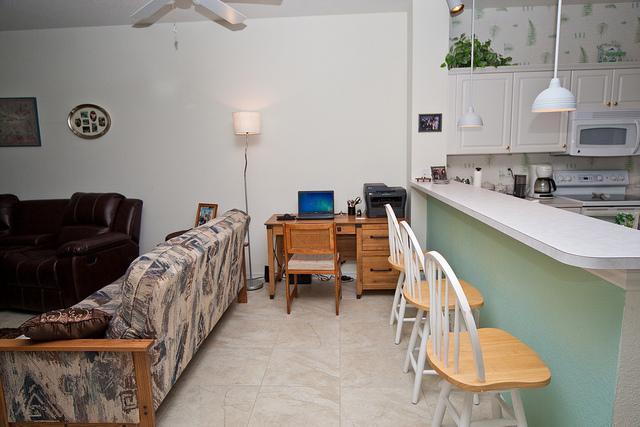How many couches are there?
Give a very brief answer. 2. How many chairs can be seen?
Give a very brief answer. 3. 